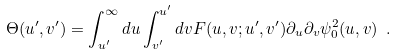<formula> <loc_0><loc_0><loc_500><loc_500>\Theta ( u ^ { \prime } , v ^ { \prime } ) = \int _ { u ^ { \prime } } ^ { \infty } d u \int _ { v ^ { \prime } } ^ { u ^ { \prime } } d v F ( u , v ; u ^ { \prime } , v ^ { \prime } ) \partial _ { u } \partial _ { v } \psi _ { 0 } ^ { 2 } ( u , v ) \ .</formula> 